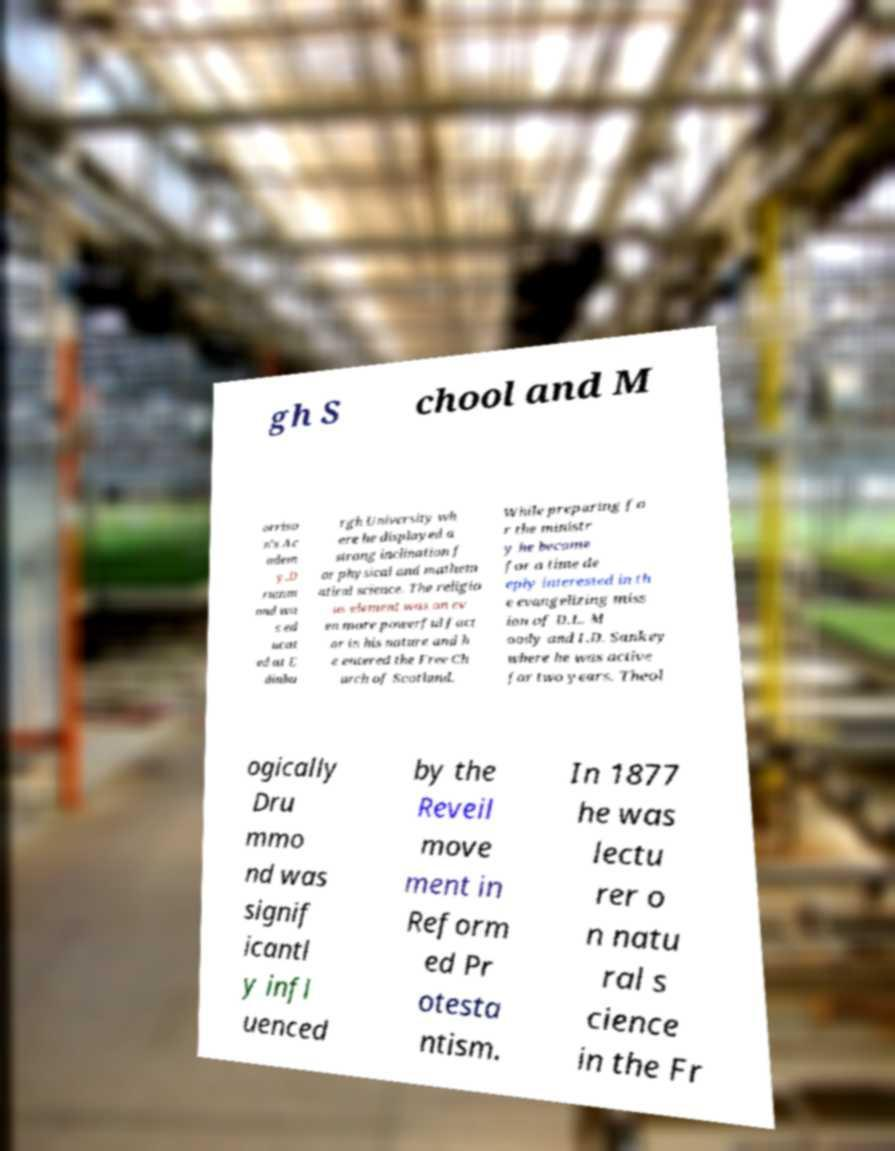What messages or text are displayed in this image? I need them in a readable, typed format. gh S chool and M orriso n's Ac adem y.D rumm ond wa s ed ucat ed at E dinbu rgh University wh ere he displayed a strong inclination f or physical and mathem atical science. The religio us element was an ev en more powerful fact or in his nature and h e entered the Free Ch urch of Scotland. While preparing fo r the ministr y he became for a time de eply interested in th e evangelizing miss ion of D.L. M oody and I.D. Sankey where he was active for two years. Theol ogically Dru mmo nd was signif icantl y infl uenced by the Reveil move ment in Reform ed Pr otesta ntism. In 1877 he was lectu rer o n natu ral s cience in the Fr 